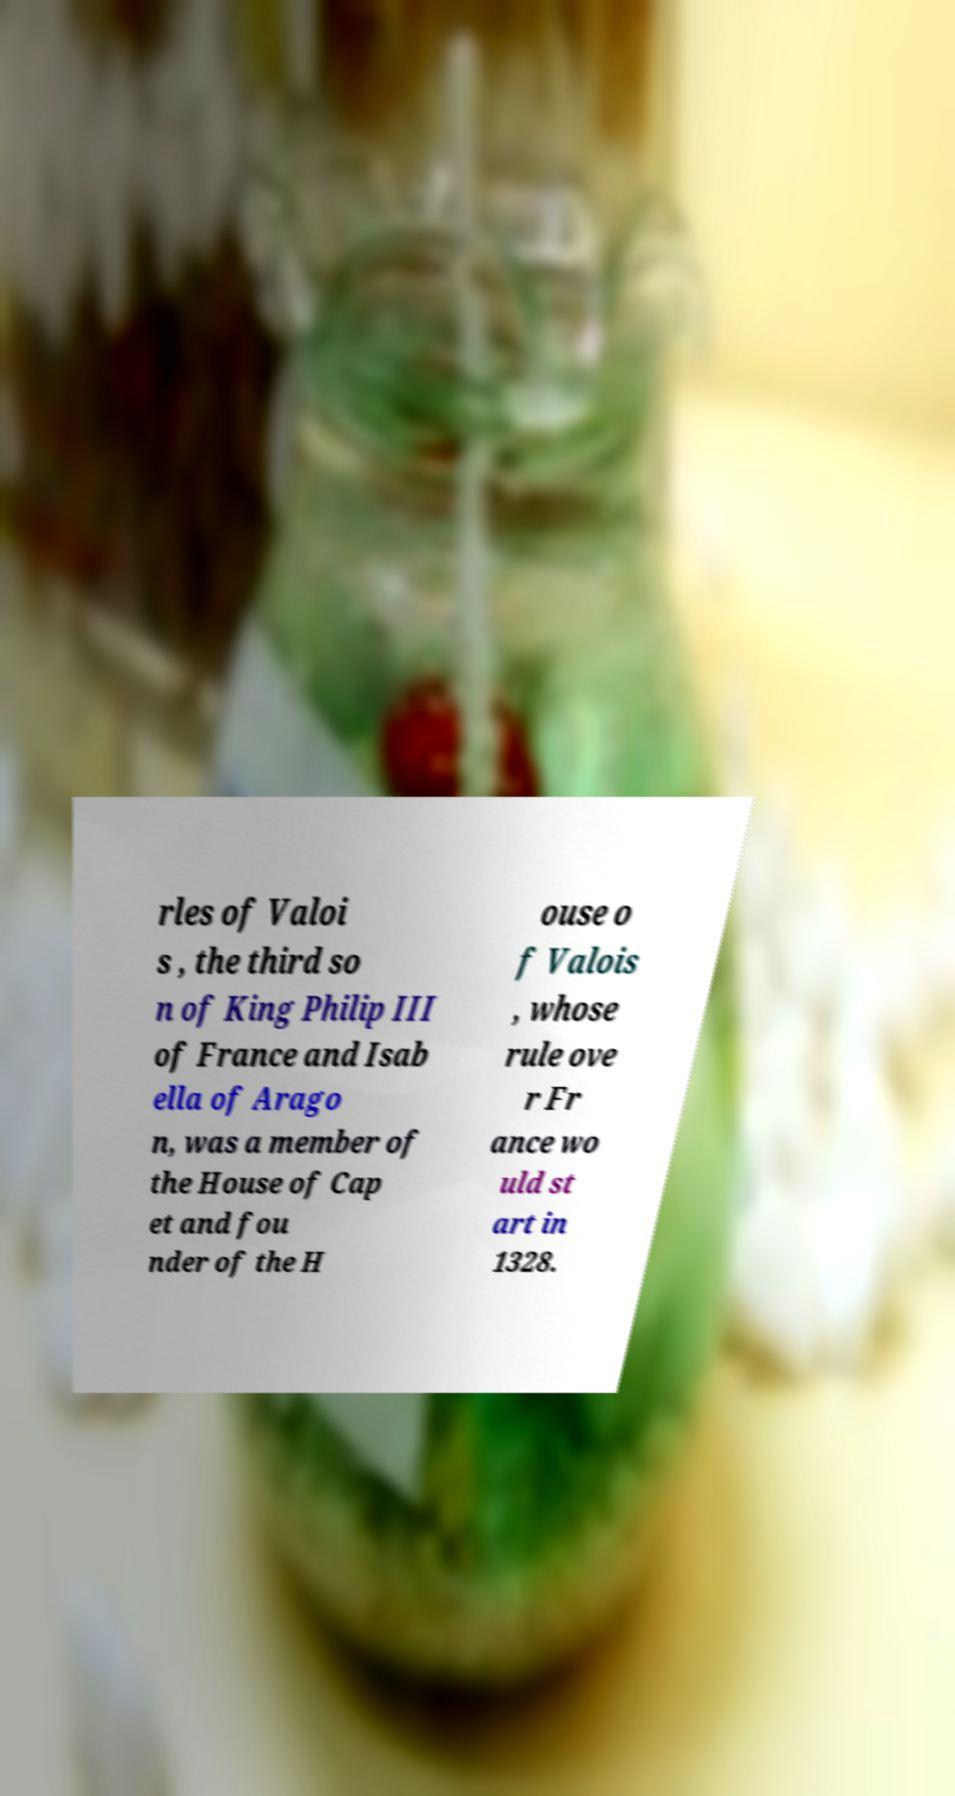For documentation purposes, I need the text within this image transcribed. Could you provide that? rles of Valoi s , the third so n of King Philip III of France and Isab ella of Arago n, was a member of the House of Cap et and fou nder of the H ouse o f Valois , whose rule ove r Fr ance wo uld st art in 1328. 